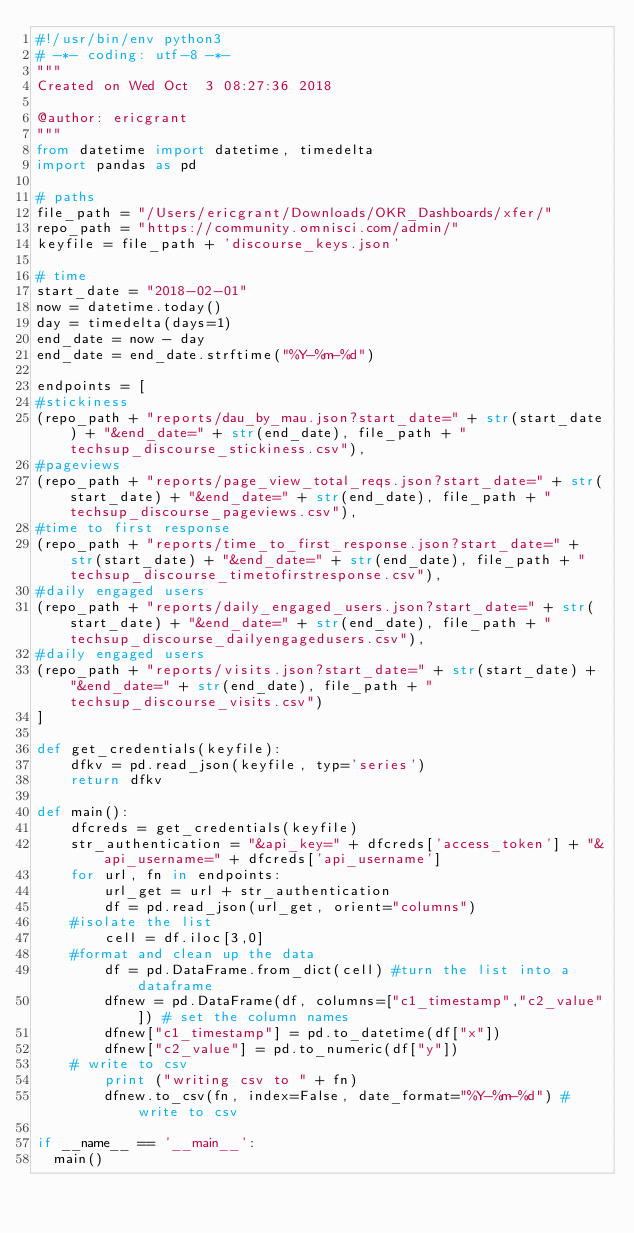Convert code to text. <code><loc_0><loc_0><loc_500><loc_500><_Python_>#!/usr/bin/env python3
# -*- coding: utf-8 -*-
"""
Created on Wed Oct  3 08:27:36 2018

@author: ericgrant
"""
from datetime import datetime, timedelta
import pandas as pd

# paths
file_path = "/Users/ericgrant/Downloads/OKR_Dashboards/xfer/"
repo_path = "https://community.omnisci.com/admin/"
keyfile = file_path + 'discourse_keys.json'

# time
start_date = "2018-02-01"
now = datetime.today()
day = timedelta(days=1)
end_date = now - day
end_date = end_date.strftime("%Y-%m-%d")

endpoints = [
#stickiness
(repo_path + "reports/dau_by_mau.json?start_date=" + str(start_date) + "&end_date=" + str(end_date), file_path + "techsup_discourse_stickiness.csv"),
#pageviews
(repo_path + "reports/page_view_total_reqs.json?start_date=" + str(start_date) + "&end_date=" + str(end_date), file_path + "techsup_discourse_pageviews.csv"),
#time to first response
(repo_path + "reports/time_to_first_response.json?start_date=" + str(start_date) + "&end_date=" + str(end_date), file_path + "techsup_discourse_timetofirstresponse.csv"),
#daily engaged users
(repo_path + "reports/daily_engaged_users.json?start_date=" + str(start_date) + "&end_date=" + str(end_date), file_path + "techsup_discourse_dailyengagedusers.csv"),
#daily engaged users
(repo_path + "reports/visits.json?start_date=" + str(start_date) + "&end_date=" + str(end_date), file_path + "techsup_discourse_visits.csv")
]

def get_credentials(keyfile):
    dfkv = pd.read_json(keyfile, typ='series')
    return dfkv

def main():
    dfcreds = get_credentials(keyfile)
    str_authentication = "&api_key=" + dfcreds['access_token'] + "&api_username=" + dfcreds['api_username']
    for url, fn in endpoints:
        url_get = url + str_authentication
        df = pd.read_json(url_get, orient="columns")
    #isolate the list
        cell = df.iloc[3,0]
    #format and clean up the data
        df = pd.DataFrame.from_dict(cell) #turn the list into a dataframe
        dfnew = pd.DataFrame(df, columns=["c1_timestamp","c2_value"]) # set the column names
        dfnew["c1_timestamp"] = pd.to_datetime(df["x"])
        dfnew["c2_value"] = pd.to_numeric(df["y"])
    # write to csv
        print ("writing csv to " + fn)
        dfnew.to_csv(fn, index=False, date_format="%Y-%m-%d") # write to csv

if __name__ == '__main__':
  main()</code> 